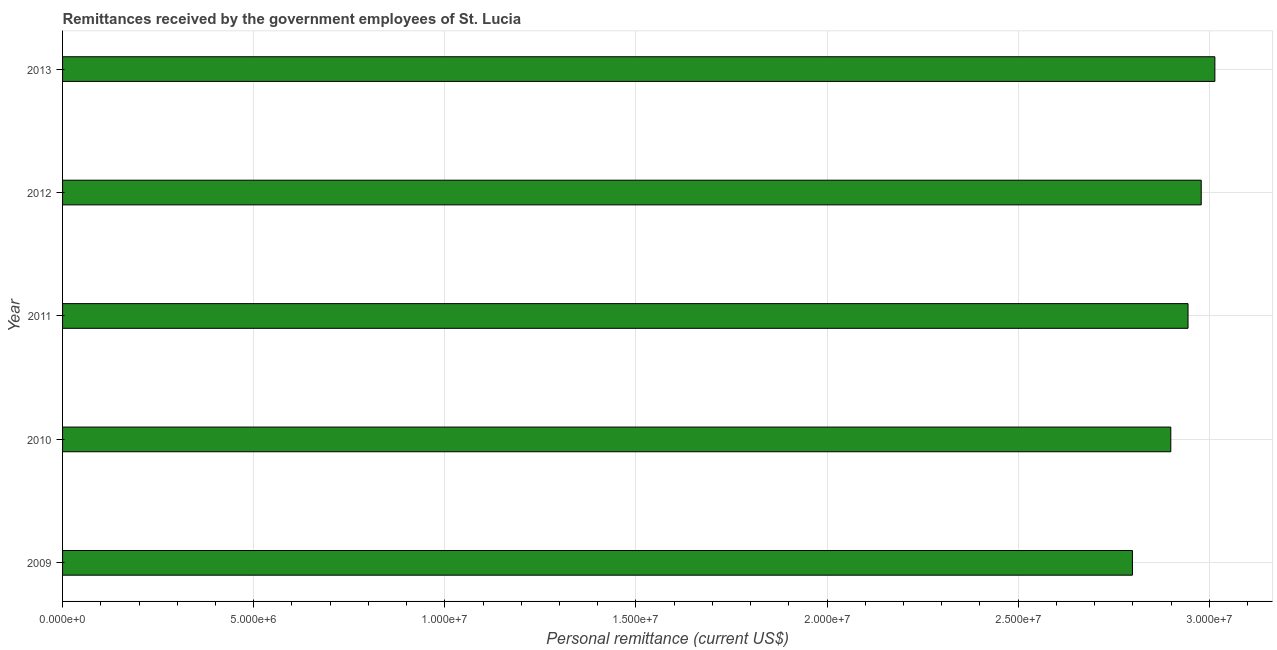What is the title of the graph?
Offer a very short reply. Remittances received by the government employees of St. Lucia. What is the label or title of the X-axis?
Make the answer very short. Personal remittance (current US$). What is the label or title of the Y-axis?
Your response must be concise. Year. What is the personal remittances in 2012?
Ensure brevity in your answer.  2.98e+07. Across all years, what is the maximum personal remittances?
Provide a succinct answer. 3.01e+07. Across all years, what is the minimum personal remittances?
Your response must be concise. 2.80e+07. In which year was the personal remittances maximum?
Your answer should be very brief. 2013. In which year was the personal remittances minimum?
Provide a short and direct response. 2009. What is the sum of the personal remittances?
Keep it short and to the point. 1.46e+08. What is the difference between the personal remittances in 2010 and 2013?
Provide a short and direct response. -1.15e+06. What is the average personal remittances per year?
Your answer should be compact. 2.93e+07. What is the median personal remittances?
Keep it short and to the point. 2.94e+07. In how many years, is the personal remittances greater than 17000000 US$?
Your answer should be compact. 5. Do a majority of the years between 2011 and 2010 (inclusive) have personal remittances greater than 6000000 US$?
Make the answer very short. No. What is the difference between the highest and the second highest personal remittances?
Keep it short and to the point. 3.57e+05. Is the sum of the personal remittances in 2009 and 2010 greater than the maximum personal remittances across all years?
Ensure brevity in your answer.  Yes. What is the difference between the highest and the lowest personal remittances?
Offer a very short reply. 2.16e+06. In how many years, is the personal remittances greater than the average personal remittances taken over all years?
Offer a very short reply. 3. Are the values on the major ticks of X-axis written in scientific E-notation?
Keep it short and to the point. Yes. What is the Personal remittance (current US$) in 2009?
Give a very brief answer. 2.80e+07. What is the Personal remittance (current US$) of 2010?
Offer a very short reply. 2.90e+07. What is the Personal remittance (current US$) in 2011?
Provide a succinct answer. 2.94e+07. What is the Personal remittance (current US$) of 2012?
Offer a very short reply. 2.98e+07. What is the Personal remittance (current US$) in 2013?
Keep it short and to the point. 3.01e+07. What is the difference between the Personal remittance (current US$) in 2009 and 2010?
Make the answer very short. -1.00e+06. What is the difference between the Personal remittance (current US$) in 2009 and 2011?
Keep it short and to the point. -1.45e+06. What is the difference between the Personal remittance (current US$) in 2009 and 2012?
Ensure brevity in your answer.  -1.80e+06. What is the difference between the Personal remittance (current US$) in 2009 and 2013?
Ensure brevity in your answer.  -2.16e+06. What is the difference between the Personal remittance (current US$) in 2010 and 2011?
Provide a succinct answer. -4.51e+05. What is the difference between the Personal remittance (current US$) in 2010 and 2012?
Offer a very short reply. -7.96e+05. What is the difference between the Personal remittance (current US$) in 2010 and 2013?
Make the answer very short. -1.15e+06. What is the difference between the Personal remittance (current US$) in 2011 and 2012?
Make the answer very short. -3.45e+05. What is the difference between the Personal remittance (current US$) in 2011 and 2013?
Provide a short and direct response. -7.02e+05. What is the difference between the Personal remittance (current US$) in 2012 and 2013?
Keep it short and to the point. -3.57e+05. What is the ratio of the Personal remittance (current US$) in 2009 to that in 2011?
Your response must be concise. 0.95. What is the ratio of the Personal remittance (current US$) in 2009 to that in 2013?
Your response must be concise. 0.93. What is the ratio of the Personal remittance (current US$) in 2010 to that in 2013?
Make the answer very short. 0.96. What is the ratio of the Personal remittance (current US$) in 2011 to that in 2012?
Provide a succinct answer. 0.99. 